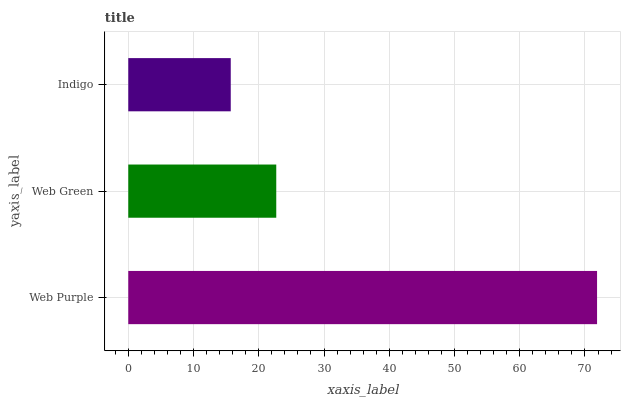Is Indigo the minimum?
Answer yes or no. Yes. Is Web Purple the maximum?
Answer yes or no. Yes. Is Web Green the minimum?
Answer yes or no. No. Is Web Green the maximum?
Answer yes or no. No. Is Web Purple greater than Web Green?
Answer yes or no. Yes. Is Web Green less than Web Purple?
Answer yes or no. Yes. Is Web Green greater than Web Purple?
Answer yes or no. No. Is Web Purple less than Web Green?
Answer yes or no. No. Is Web Green the high median?
Answer yes or no. Yes. Is Web Green the low median?
Answer yes or no. Yes. Is Web Purple the high median?
Answer yes or no. No. Is Indigo the low median?
Answer yes or no. No. 